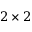Convert formula to latex. <formula><loc_0><loc_0><loc_500><loc_500>2 \times 2</formula> 